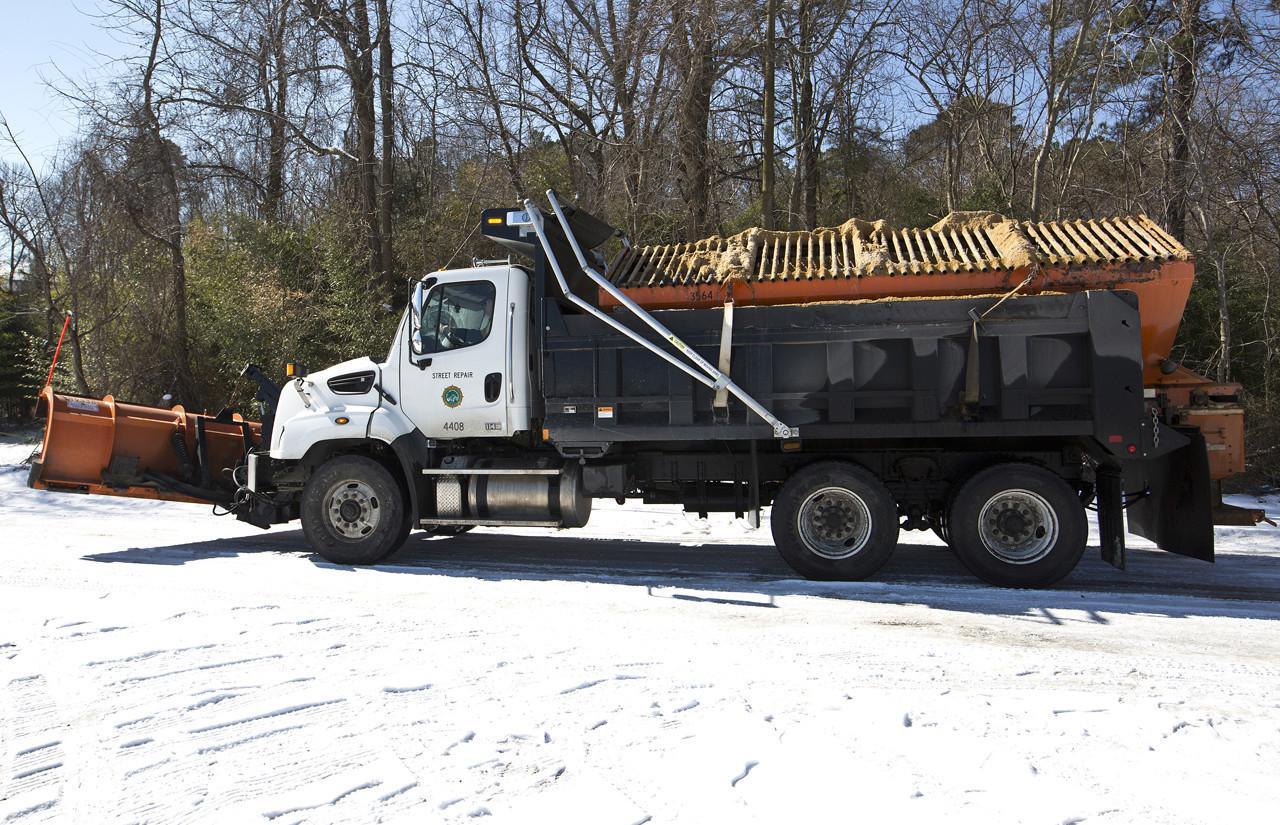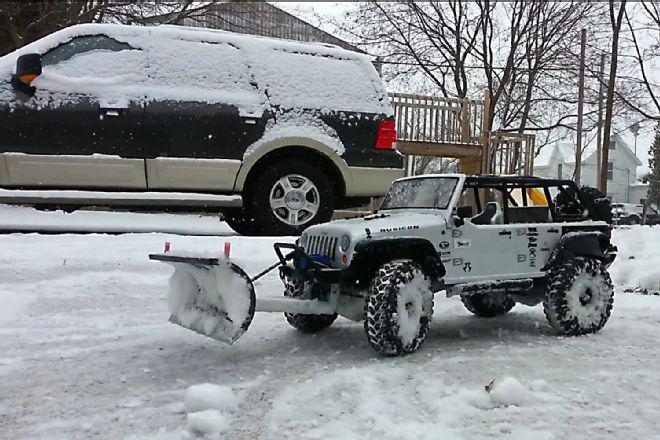The first image is the image on the left, the second image is the image on the right. Assess this claim about the two images: "An image features a truck with an orange plow and orange cab.". Correct or not? Answer yes or no. No. The first image is the image on the left, the second image is the image on the right. Analyze the images presented: Is the assertion "An orange truck has a plow on the front of it." valid? Answer yes or no. No. 